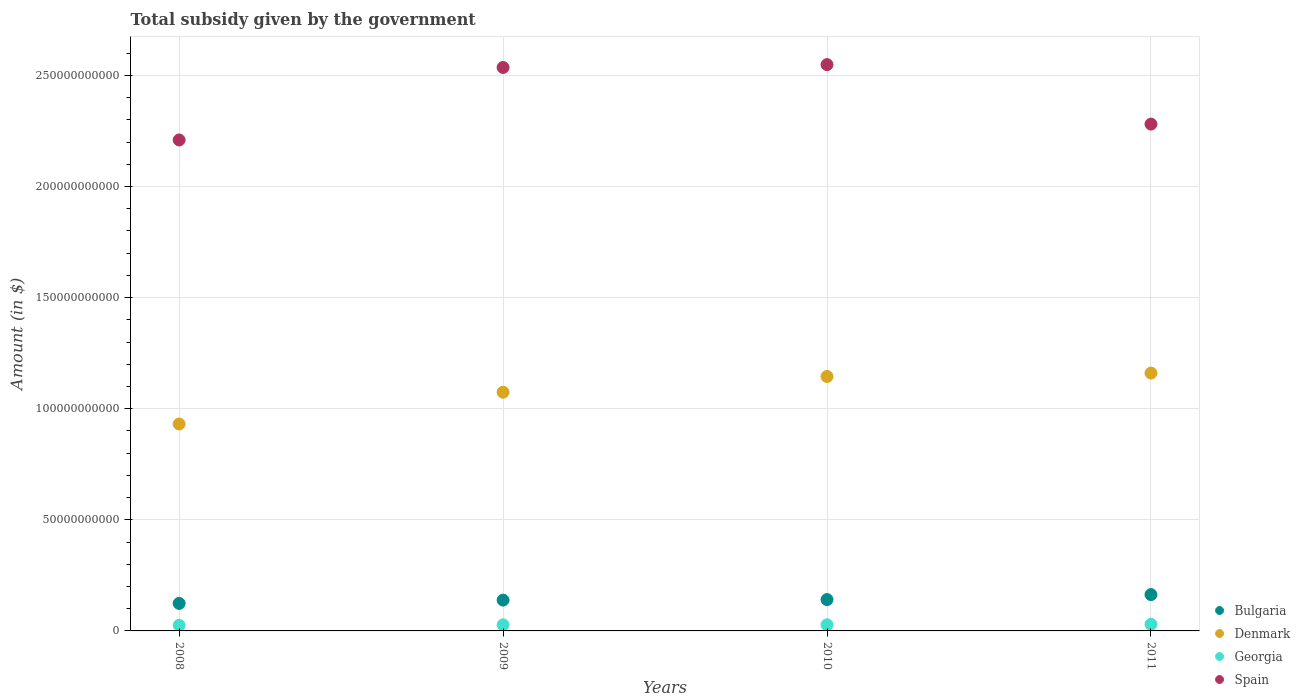How many different coloured dotlines are there?
Make the answer very short. 4. Is the number of dotlines equal to the number of legend labels?
Offer a very short reply. Yes. What is the total revenue collected by the government in Georgia in 2010?
Provide a succinct answer. 2.78e+09. Across all years, what is the maximum total revenue collected by the government in Denmark?
Your answer should be compact. 1.16e+11. Across all years, what is the minimum total revenue collected by the government in Spain?
Offer a terse response. 2.21e+11. In which year was the total revenue collected by the government in Denmark maximum?
Offer a very short reply. 2011. In which year was the total revenue collected by the government in Denmark minimum?
Offer a terse response. 2008. What is the total total revenue collected by the government in Denmark in the graph?
Give a very brief answer. 4.31e+11. What is the difference between the total revenue collected by the government in Spain in 2008 and that in 2010?
Offer a terse response. -3.39e+1. What is the difference between the total revenue collected by the government in Denmark in 2011 and the total revenue collected by the government in Bulgaria in 2008?
Offer a very short reply. 1.04e+11. What is the average total revenue collected by the government in Bulgaria per year?
Make the answer very short. 1.42e+1. In the year 2011, what is the difference between the total revenue collected by the government in Denmark and total revenue collected by the government in Bulgaria?
Offer a very short reply. 9.97e+1. What is the ratio of the total revenue collected by the government in Georgia in 2009 to that in 2010?
Ensure brevity in your answer.  0.98. Is the total revenue collected by the government in Denmark in 2008 less than that in 2010?
Keep it short and to the point. Yes. Is the difference between the total revenue collected by the government in Denmark in 2008 and 2010 greater than the difference between the total revenue collected by the government in Bulgaria in 2008 and 2010?
Make the answer very short. No. What is the difference between the highest and the second highest total revenue collected by the government in Bulgaria?
Your answer should be compact. 2.24e+09. What is the difference between the highest and the lowest total revenue collected by the government in Bulgaria?
Your answer should be compact. 3.96e+09. In how many years, is the total revenue collected by the government in Georgia greater than the average total revenue collected by the government in Georgia taken over all years?
Provide a short and direct response. 2. Is the sum of the total revenue collected by the government in Denmark in 2010 and 2011 greater than the maximum total revenue collected by the government in Bulgaria across all years?
Ensure brevity in your answer.  Yes. Is it the case that in every year, the sum of the total revenue collected by the government in Spain and total revenue collected by the government in Georgia  is greater than the total revenue collected by the government in Denmark?
Ensure brevity in your answer.  Yes. Does the total revenue collected by the government in Spain monotonically increase over the years?
Your answer should be compact. No. Is the total revenue collected by the government in Spain strictly greater than the total revenue collected by the government in Denmark over the years?
Provide a succinct answer. Yes. Is the total revenue collected by the government in Denmark strictly less than the total revenue collected by the government in Georgia over the years?
Provide a short and direct response. No. How many dotlines are there?
Your answer should be compact. 4. Are the values on the major ticks of Y-axis written in scientific E-notation?
Your answer should be very brief. No. Does the graph contain any zero values?
Your response must be concise. No. Does the graph contain grids?
Your answer should be compact. Yes. How many legend labels are there?
Make the answer very short. 4. How are the legend labels stacked?
Ensure brevity in your answer.  Vertical. What is the title of the graph?
Keep it short and to the point. Total subsidy given by the government. What is the label or title of the Y-axis?
Provide a short and direct response. Amount (in $). What is the Amount (in $) of Bulgaria in 2008?
Keep it short and to the point. 1.24e+1. What is the Amount (in $) of Denmark in 2008?
Your answer should be very brief. 9.31e+1. What is the Amount (in $) of Georgia in 2008?
Your answer should be very brief. 2.51e+09. What is the Amount (in $) of Spain in 2008?
Ensure brevity in your answer.  2.21e+11. What is the Amount (in $) of Bulgaria in 2009?
Give a very brief answer. 1.39e+1. What is the Amount (in $) in Denmark in 2009?
Your response must be concise. 1.07e+11. What is the Amount (in $) of Georgia in 2009?
Make the answer very short. 2.73e+09. What is the Amount (in $) in Spain in 2009?
Offer a terse response. 2.54e+11. What is the Amount (in $) of Bulgaria in 2010?
Give a very brief answer. 1.41e+1. What is the Amount (in $) in Denmark in 2010?
Make the answer very short. 1.15e+11. What is the Amount (in $) in Georgia in 2010?
Provide a short and direct response. 2.78e+09. What is the Amount (in $) of Spain in 2010?
Keep it short and to the point. 2.55e+11. What is the Amount (in $) in Bulgaria in 2011?
Keep it short and to the point. 1.63e+1. What is the Amount (in $) in Denmark in 2011?
Your answer should be very brief. 1.16e+11. What is the Amount (in $) in Georgia in 2011?
Your answer should be compact. 2.96e+09. What is the Amount (in $) in Spain in 2011?
Give a very brief answer. 2.28e+11. Across all years, what is the maximum Amount (in $) of Bulgaria?
Your answer should be very brief. 1.63e+1. Across all years, what is the maximum Amount (in $) of Denmark?
Ensure brevity in your answer.  1.16e+11. Across all years, what is the maximum Amount (in $) of Georgia?
Your answer should be compact. 2.96e+09. Across all years, what is the maximum Amount (in $) in Spain?
Provide a short and direct response. 2.55e+11. Across all years, what is the minimum Amount (in $) of Bulgaria?
Ensure brevity in your answer.  1.24e+1. Across all years, what is the minimum Amount (in $) in Denmark?
Ensure brevity in your answer.  9.31e+1. Across all years, what is the minimum Amount (in $) in Georgia?
Your answer should be compact. 2.51e+09. Across all years, what is the minimum Amount (in $) of Spain?
Ensure brevity in your answer.  2.21e+11. What is the total Amount (in $) in Bulgaria in the graph?
Ensure brevity in your answer.  5.67e+1. What is the total Amount (in $) of Denmark in the graph?
Your answer should be compact. 4.31e+11. What is the total Amount (in $) in Georgia in the graph?
Give a very brief answer. 1.10e+1. What is the total Amount (in $) in Spain in the graph?
Your answer should be compact. 9.57e+11. What is the difference between the Amount (in $) of Bulgaria in 2008 and that in 2009?
Your answer should be very brief. -1.48e+09. What is the difference between the Amount (in $) in Denmark in 2008 and that in 2009?
Your answer should be compact. -1.43e+1. What is the difference between the Amount (in $) of Georgia in 2008 and that in 2009?
Offer a very short reply. -2.21e+08. What is the difference between the Amount (in $) in Spain in 2008 and that in 2009?
Make the answer very short. -3.26e+1. What is the difference between the Amount (in $) in Bulgaria in 2008 and that in 2010?
Offer a very short reply. -1.72e+09. What is the difference between the Amount (in $) in Denmark in 2008 and that in 2010?
Make the answer very short. -2.14e+1. What is the difference between the Amount (in $) in Georgia in 2008 and that in 2010?
Your answer should be compact. -2.70e+08. What is the difference between the Amount (in $) of Spain in 2008 and that in 2010?
Ensure brevity in your answer.  -3.39e+1. What is the difference between the Amount (in $) in Bulgaria in 2008 and that in 2011?
Make the answer very short. -3.96e+09. What is the difference between the Amount (in $) of Denmark in 2008 and that in 2011?
Your response must be concise. -2.29e+1. What is the difference between the Amount (in $) in Georgia in 2008 and that in 2011?
Your response must be concise. -4.50e+08. What is the difference between the Amount (in $) of Spain in 2008 and that in 2011?
Give a very brief answer. -7.13e+09. What is the difference between the Amount (in $) in Bulgaria in 2009 and that in 2010?
Your response must be concise. -2.37e+08. What is the difference between the Amount (in $) in Denmark in 2009 and that in 2010?
Offer a terse response. -7.08e+09. What is the difference between the Amount (in $) of Georgia in 2009 and that in 2010?
Give a very brief answer. -4.86e+07. What is the difference between the Amount (in $) in Spain in 2009 and that in 2010?
Your answer should be compact. -1.29e+09. What is the difference between the Amount (in $) in Bulgaria in 2009 and that in 2011?
Offer a terse response. -2.48e+09. What is the difference between the Amount (in $) in Denmark in 2009 and that in 2011?
Ensure brevity in your answer.  -8.61e+09. What is the difference between the Amount (in $) of Georgia in 2009 and that in 2011?
Offer a terse response. -2.29e+08. What is the difference between the Amount (in $) of Spain in 2009 and that in 2011?
Provide a short and direct response. 2.55e+1. What is the difference between the Amount (in $) in Bulgaria in 2010 and that in 2011?
Make the answer very short. -2.24e+09. What is the difference between the Amount (in $) in Denmark in 2010 and that in 2011?
Give a very brief answer. -1.53e+09. What is the difference between the Amount (in $) of Georgia in 2010 and that in 2011?
Provide a short and direct response. -1.81e+08. What is the difference between the Amount (in $) of Spain in 2010 and that in 2011?
Provide a short and direct response. 2.68e+1. What is the difference between the Amount (in $) in Bulgaria in 2008 and the Amount (in $) in Denmark in 2009?
Keep it short and to the point. -9.50e+1. What is the difference between the Amount (in $) of Bulgaria in 2008 and the Amount (in $) of Georgia in 2009?
Provide a succinct answer. 9.66e+09. What is the difference between the Amount (in $) of Bulgaria in 2008 and the Amount (in $) of Spain in 2009?
Give a very brief answer. -2.41e+11. What is the difference between the Amount (in $) of Denmark in 2008 and the Amount (in $) of Georgia in 2009?
Your answer should be very brief. 9.04e+1. What is the difference between the Amount (in $) of Denmark in 2008 and the Amount (in $) of Spain in 2009?
Your response must be concise. -1.60e+11. What is the difference between the Amount (in $) in Georgia in 2008 and the Amount (in $) in Spain in 2009?
Your answer should be very brief. -2.51e+11. What is the difference between the Amount (in $) in Bulgaria in 2008 and the Amount (in $) in Denmark in 2010?
Your answer should be compact. -1.02e+11. What is the difference between the Amount (in $) of Bulgaria in 2008 and the Amount (in $) of Georgia in 2010?
Give a very brief answer. 9.61e+09. What is the difference between the Amount (in $) in Bulgaria in 2008 and the Amount (in $) in Spain in 2010?
Keep it short and to the point. -2.42e+11. What is the difference between the Amount (in $) in Denmark in 2008 and the Amount (in $) in Georgia in 2010?
Keep it short and to the point. 9.04e+1. What is the difference between the Amount (in $) in Denmark in 2008 and the Amount (in $) in Spain in 2010?
Your answer should be compact. -1.62e+11. What is the difference between the Amount (in $) of Georgia in 2008 and the Amount (in $) of Spain in 2010?
Your response must be concise. -2.52e+11. What is the difference between the Amount (in $) in Bulgaria in 2008 and the Amount (in $) in Denmark in 2011?
Offer a terse response. -1.04e+11. What is the difference between the Amount (in $) of Bulgaria in 2008 and the Amount (in $) of Georgia in 2011?
Your response must be concise. 9.43e+09. What is the difference between the Amount (in $) in Bulgaria in 2008 and the Amount (in $) in Spain in 2011?
Your answer should be compact. -2.16e+11. What is the difference between the Amount (in $) in Denmark in 2008 and the Amount (in $) in Georgia in 2011?
Your answer should be compact. 9.02e+1. What is the difference between the Amount (in $) of Denmark in 2008 and the Amount (in $) of Spain in 2011?
Your answer should be very brief. -1.35e+11. What is the difference between the Amount (in $) of Georgia in 2008 and the Amount (in $) of Spain in 2011?
Your answer should be very brief. -2.26e+11. What is the difference between the Amount (in $) in Bulgaria in 2009 and the Amount (in $) in Denmark in 2010?
Keep it short and to the point. -1.01e+11. What is the difference between the Amount (in $) of Bulgaria in 2009 and the Amount (in $) of Georgia in 2010?
Make the answer very short. 1.11e+1. What is the difference between the Amount (in $) of Bulgaria in 2009 and the Amount (in $) of Spain in 2010?
Make the answer very short. -2.41e+11. What is the difference between the Amount (in $) in Denmark in 2009 and the Amount (in $) in Georgia in 2010?
Your answer should be compact. 1.05e+11. What is the difference between the Amount (in $) of Denmark in 2009 and the Amount (in $) of Spain in 2010?
Your answer should be very brief. -1.47e+11. What is the difference between the Amount (in $) of Georgia in 2009 and the Amount (in $) of Spain in 2010?
Offer a terse response. -2.52e+11. What is the difference between the Amount (in $) of Bulgaria in 2009 and the Amount (in $) of Denmark in 2011?
Provide a short and direct response. -1.02e+11. What is the difference between the Amount (in $) in Bulgaria in 2009 and the Amount (in $) in Georgia in 2011?
Your answer should be very brief. 1.09e+1. What is the difference between the Amount (in $) in Bulgaria in 2009 and the Amount (in $) in Spain in 2011?
Your response must be concise. -2.14e+11. What is the difference between the Amount (in $) of Denmark in 2009 and the Amount (in $) of Georgia in 2011?
Give a very brief answer. 1.04e+11. What is the difference between the Amount (in $) of Denmark in 2009 and the Amount (in $) of Spain in 2011?
Give a very brief answer. -1.21e+11. What is the difference between the Amount (in $) of Georgia in 2009 and the Amount (in $) of Spain in 2011?
Provide a short and direct response. -2.25e+11. What is the difference between the Amount (in $) in Bulgaria in 2010 and the Amount (in $) in Denmark in 2011?
Offer a terse response. -1.02e+11. What is the difference between the Amount (in $) in Bulgaria in 2010 and the Amount (in $) in Georgia in 2011?
Provide a succinct answer. 1.11e+1. What is the difference between the Amount (in $) in Bulgaria in 2010 and the Amount (in $) in Spain in 2011?
Make the answer very short. -2.14e+11. What is the difference between the Amount (in $) in Denmark in 2010 and the Amount (in $) in Georgia in 2011?
Keep it short and to the point. 1.12e+11. What is the difference between the Amount (in $) of Denmark in 2010 and the Amount (in $) of Spain in 2011?
Keep it short and to the point. -1.14e+11. What is the difference between the Amount (in $) in Georgia in 2010 and the Amount (in $) in Spain in 2011?
Offer a very short reply. -2.25e+11. What is the average Amount (in $) in Bulgaria per year?
Provide a succinct answer. 1.42e+1. What is the average Amount (in $) in Denmark per year?
Provide a succinct answer. 1.08e+11. What is the average Amount (in $) of Georgia per year?
Your response must be concise. 2.74e+09. What is the average Amount (in $) of Spain per year?
Provide a succinct answer. 2.39e+11. In the year 2008, what is the difference between the Amount (in $) of Bulgaria and Amount (in $) of Denmark?
Ensure brevity in your answer.  -8.07e+1. In the year 2008, what is the difference between the Amount (in $) in Bulgaria and Amount (in $) in Georgia?
Your answer should be compact. 9.88e+09. In the year 2008, what is the difference between the Amount (in $) of Bulgaria and Amount (in $) of Spain?
Offer a very short reply. -2.09e+11. In the year 2008, what is the difference between the Amount (in $) of Denmark and Amount (in $) of Georgia?
Your answer should be compact. 9.06e+1. In the year 2008, what is the difference between the Amount (in $) in Denmark and Amount (in $) in Spain?
Your response must be concise. -1.28e+11. In the year 2008, what is the difference between the Amount (in $) in Georgia and Amount (in $) in Spain?
Make the answer very short. -2.18e+11. In the year 2009, what is the difference between the Amount (in $) of Bulgaria and Amount (in $) of Denmark?
Give a very brief answer. -9.36e+1. In the year 2009, what is the difference between the Amount (in $) of Bulgaria and Amount (in $) of Georgia?
Offer a terse response. 1.11e+1. In the year 2009, what is the difference between the Amount (in $) of Bulgaria and Amount (in $) of Spain?
Give a very brief answer. -2.40e+11. In the year 2009, what is the difference between the Amount (in $) of Denmark and Amount (in $) of Georgia?
Give a very brief answer. 1.05e+11. In the year 2009, what is the difference between the Amount (in $) in Denmark and Amount (in $) in Spain?
Your response must be concise. -1.46e+11. In the year 2009, what is the difference between the Amount (in $) in Georgia and Amount (in $) in Spain?
Provide a succinct answer. -2.51e+11. In the year 2010, what is the difference between the Amount (in $) in Bulgaria and Amount (in $) in Denmark?
Ensure brevity in your answer.  -1.00e+11. In the year 2010, what is the difference between the Amount (in $) of Bulgaria and Amount (in $) of Georgia?
Offer a terse response. 1.13e+1. In the year 2010, what is the difference between the Amount (in $) of Bulgaria and Amount (in $) of Spain?
Keep it short and to the point. -2.41e+11. In the year 2010, what is the difference between the Amount (in $) of Denmark and Amount (in $) of Georgia?
Offer a very short reply. 1.12e+11. In the year 2010, what is the difference between the Amount (in $) of Denmark and Amount (in $) of Spain?
Provide a succinct answer. -1.40e+11. In the year 2010, what is the difference between the Amount (in $) in Georgia and Amount (in $) in Spain?
Make the answer very short. -2.52e+11. In the year 2011, what is the difference between the Amount (in $) in Bulgaria and Amount (in $) in Denmark?
Your answer should be compact. -9.97e+1. In the year 2011, what is the difference between the Amount (in $) in Bulgaria and Amount (in $) in Georgia?
Your answer should be very brief. 1.34e+1. In the year 2011, what is the difference between the Amount (in $) in Bulgaria and Amount (in $) in Spain?
Your response must be concise. -2.12e+11. In the year 2011, what is the difference between the Amount (in $) in Denmark and Amount (in $) in Georgia?
Provide a succinct answer. 1.13e+11. In the year 2011, what is the difference between the Amount (in $) of Denmark and Amount (in $) of Spain?
Offer a very short reply. -1.12e+11. In the year 2011, what is the difference between the Amount (in $) in Georgia and Amount (in $) in Spain?
Offer a very short reply. -2.25e+11. What is the ratio of the Amount (in $) in Bulgaria in 2008 to that in 2009?
Ensure brevity in your answer.  0.89. What is the ratio of the Amount (in $) in Denmark in 2008 to that in 2009?
Make the answer very short. 0.87. What is the ratio of the Amount (in $) in Georgia in 2008 to that in 2009?
Your response must be concise. 0.92. What is the ratio of the Amount (in $) in Spain in 2008 to that in 2009?
Provide a short and direct response. 0.87. What is the ratio of the Amount (in $) of Bulgaria in 2008 to that in 2010?
Give a very brief answer. 0.88. What is the ratio of the Amount (in $) in Denmark in 2008 to that in 2010?
Keep it short and to the point. 0.81. What is the ratio of the Amount (in $) in Georgia in 2008 to that in 2010?
Offer a very short reply. 0.9. What is the ratio of the Amount (in $) of Spain in 2008 to that in 2010?
Your response must be concise. 0.87. What is the ratio of the Amount (in $) of Bulgaria in 2008 to that in 2011?
Give a very brief answer. 0.76. What is the ratio of the Amount (in $) of Denmark in 2008 to that in 2011?
Give a very brief answer. 0.8. What is the ratio of the Amount (in $) of Georgia in 2008 to that in 2011?
Ensure brevity in your answer.  0.85. What is the ratio of the Amount (in $) in Spain in 2008 to that in 2011?
Ensure brevity in your answer.  0.97. What is the ratio of the Amount (in $) in Bulgaria in 2009 to that in 2010?
Offer a terse response. 0.98. What is the ratio of the Amount (in $) of Denmark in 2009 to that in 2010?
Offer a terse response. 0.94. What is the ratio of the Amount (in $) of Georgia in 2009 to that in 2010?
Offer a very short reply. 0.98. What is the ratio of the Amount (in $) in Spain in 2009 to that in 2010?
Provide a succinct answer. 0.99. What is the ratio of the Amount (in $) of Bulgaria in 2009 to that in 2011?
Make the answer very short. 0.85. What is the ratio of the Amount (in $) of Denmark in 2009 to that in 2011?
Give a very brief answer. 0.93. What is the ratio of the Amount (in $) in Georgia in 2009 to that in 2011?
Give a very brief answer. 0.92. What is the ratio of the Amount (in $) of Spain in 2009 to that in 2011?
Your answer should be very brief. 1.11. What is the ratio of the Amount (in $) in Bulgaria in 2010 to that in 2011?
Provide a short and direct response. 0.86. What is the ratio of the Amount (in $) of Denmark in 2010 to that in 2011?
Your answer should be very brief. 0.99. What is the ratio of the Amount (in $) in Georgia in 2010 to that in 2011?
Offer a very short reply. 0.94. What is the ratio of the Amount (in $) in Spain in 2010 to that in 2011?
Your answer should be very brief. 1.12. What is the difference between the highest and the second highest Amount (in $) of Bulgaria?
Provide a short and direct response. 2.24e+09. What is the difference between the highest and the second highest Amount (in $) of Denmark?
Your answer should be very brief. 1.53e+09. What is the difference between the highest and the second highest Amount (in $) in Georgia?
Ensure brevity in your answer.  1.81e+08. What is the difference between the highest and the second highest Amount (in $) in Spain?
Provide a short and direct response. 1.29e+09. What is the difference between the highest and the lowest Amount (in $) in Bulgaria?
Provide a succinct answer. 3.96e+09. What is the difference between the highest and the lowest Amount (in $) of Denmark?
Keep it short and to the point. 2.29e+1. What is the difference between the highest and the lowest Amount (in $) of Georgia?
Your answer should be compact. 4.50e+08. What is the difference between the highest and the lowest Amount (in $) of Spain?
Provide a succinct answer. 3.39e+1. 